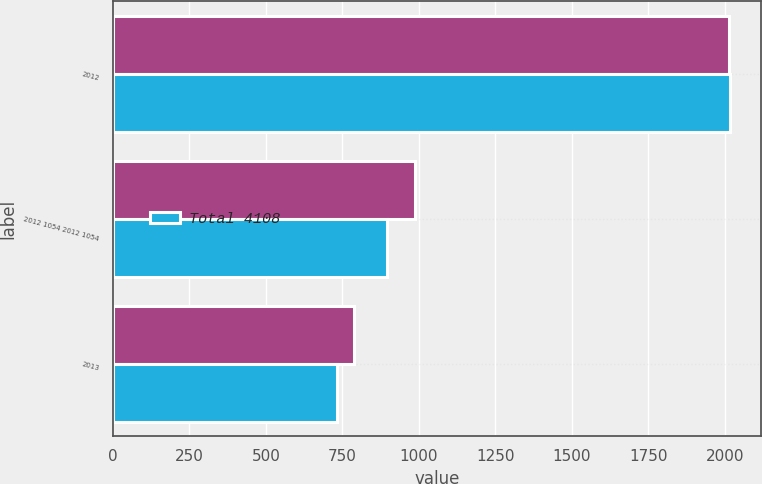Convert chart to OTSL. <chart><loc_0><loc_0><loc_500><loc_500><stacked_bar_chart><ecel><fcel>2012<fcel>2012 1054 2012 1054<fcel>2013<nl><fcel>nan<fcel>2013<fcel>988<fcel>789<nl><fcel>Total 4108<fcel>2016<fcel>895<fcel>731<nl></chart> 